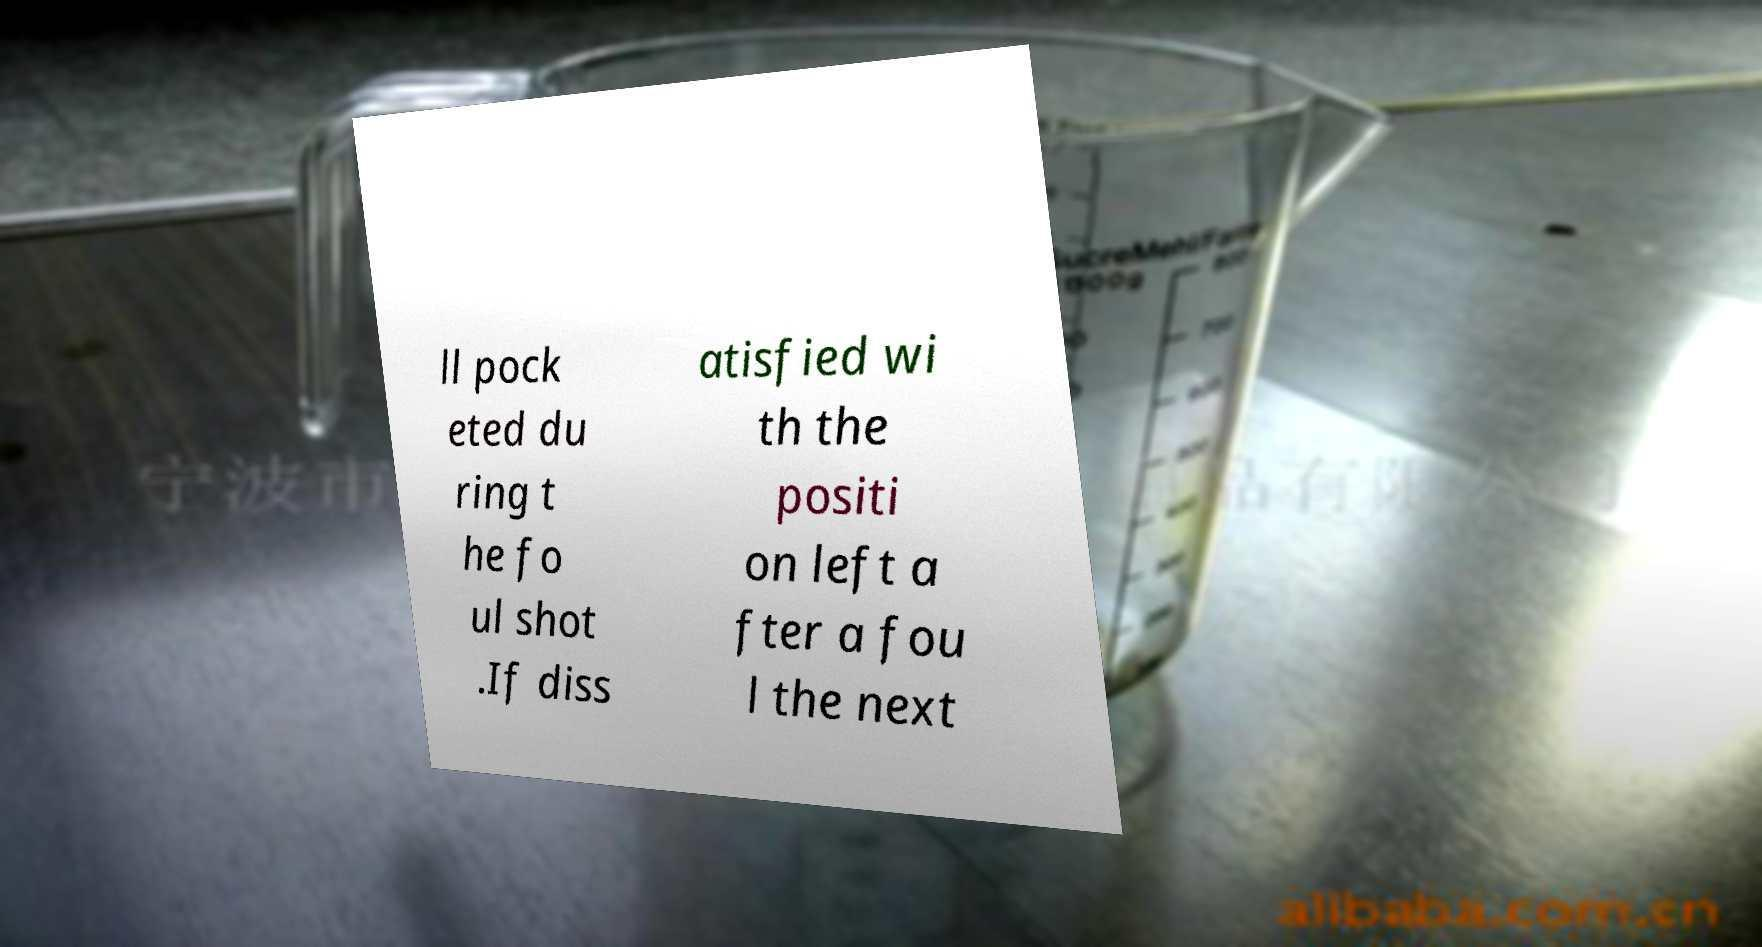Please read and relay the text visible in this image. What does it say? ll pock eted du ring t he fo ul shot .If diss atisfied wi th the positi on left a fter a fou l the next 